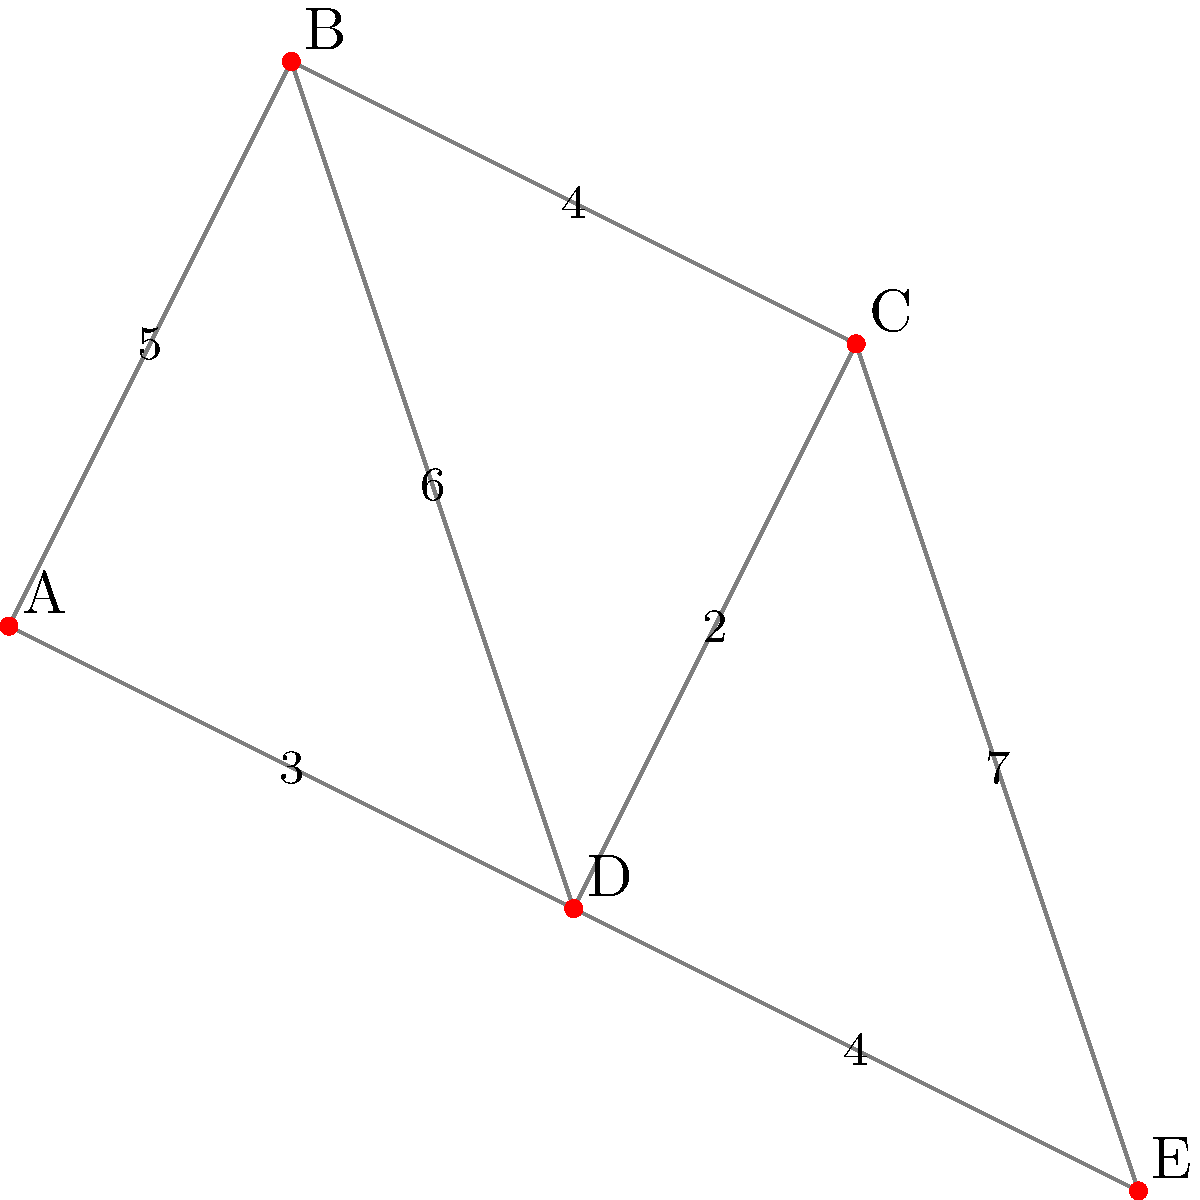As a resident of Tapiola, Espoo, you're involved in optimizing the waste collection routes. The given weighted graph represents different collection points in Tapiola, where vertices are collection points and edge weights represent distances in kilometers. What is the minimum total distance required to visit all collection points starting from point A and returning to A? To find the minimum total distance to visit all collection points and return to the starting point, we need to solve the Traveling Salesman Problem (TSP). For this small graph, we can use a brute-force approach:

1. List all possible routes starting and ending at A:
   A-B-C-D-E-A, A-B-C-E-D-A, A-B-D-C-E-A, A-B-D-E-C-A, A-B-E-C-D-A, A-B-E-D-C-A,
   A-D-B-C-E-A, A-D-B-E-C-A, A-D-C-B-E-A, A-D-C-E-B-A, A-D-E-B-C-A, A-D-E-C-B-A

2. Calculate the total distance for each route:
   A-B-C-D-E-A: 5 + 4 + 2 + 4 + 3 = 18 km
   A-B-C-E-D-A: 5 + 4 + 7 + 4 + 3 = 23 km
   A-B-D-C-E-A: 5 + 6 + 2 + 7 + 3 = 23 km
   A-B-D-E-C-A: 5 + 6 + 4 + 7 + 4 = 26 km
   A-B-E-C-D-A: 5 + (6+4) + 7 + 2 + 3 = 27 km
   A-B-E-D-C-A: 5 + (6+4) + 4 + 2 + 4 = 25 km
   A-D-B-C-E-A: 3 + 6 + 4 + 7 + 3 = 23 km
   A-D-B-E-C-A: 3 + 6 + (6+4) + 7 + 4 = 30 km
   A-D-C-B-E-A: 3 + 2 + 4 + (6+4) + 3 = 22 km
   A-D-C-E-B-A: 3 + 2 + 7 + (6+4) + 5 = 27 km
   A-D-E-B-C-A: 3 + 4 + (6+4) + 4 + 4 = 25 km
   A-D-E-C-B-A: 3 + 4 + 7 + 4 + 5 = 23 km

3. Identify the route with the minimum total distance:
   The minimum distance is 18 km, corresponding to the route A-B-C-D-E-A.
Answer: 18 km 